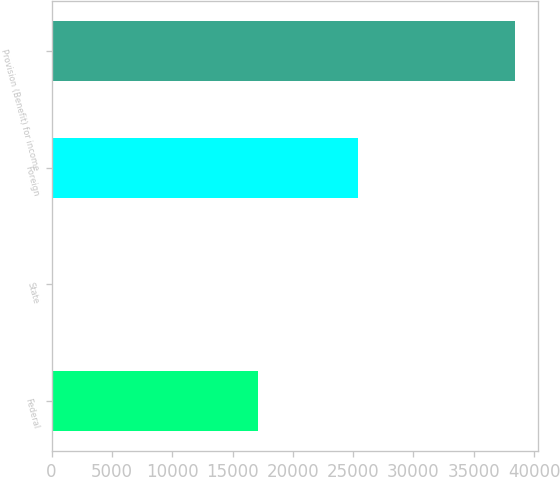Convert chart to OTSL. <chart><loc_0><loc_0><loc_500><loc_500><bar_chart><fcel>Federal<fcel>State<fcel>Foreign<fcel>Provision (Benefit) for income<nl><fcel>17097<fcel>8<fcel>25421<fcel>38405<nl></chart> 